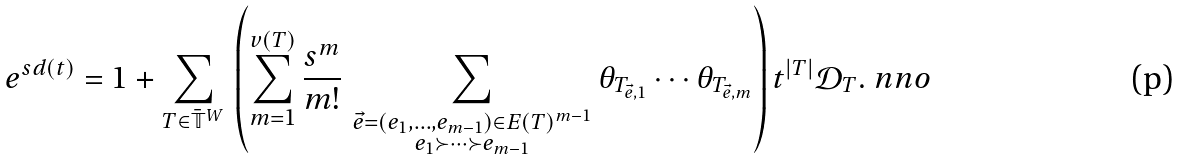Convert formula to latex. <formula><loc_0><loc_0><loc_500><loc_500>e ^ { s d ( t ) } = 1 + \sum _ { T \in \bar { \mathbb { T } } ^ { W } } \, \left ( \sum _ { m = 1 } ^ { v ( T ) } \frac { s ^ { m } } { m ! } \, \sum _ { \substack { \vec { e } = ( e _ { 1 } , \dots , e _ { m - 1 } ) \in E ( T ) ^ { m - 1 } \\ e _ { 1 } \succ \cdots \succ e _ { m - 1 } } } \theta _ { T _ { \vec { e } , 1 } } \cdots \theta _ { T _ { \vec { e } , m } } \right ) t ^ { | T | } \mathcal { D } _ { T } . \ n n o</formula> 